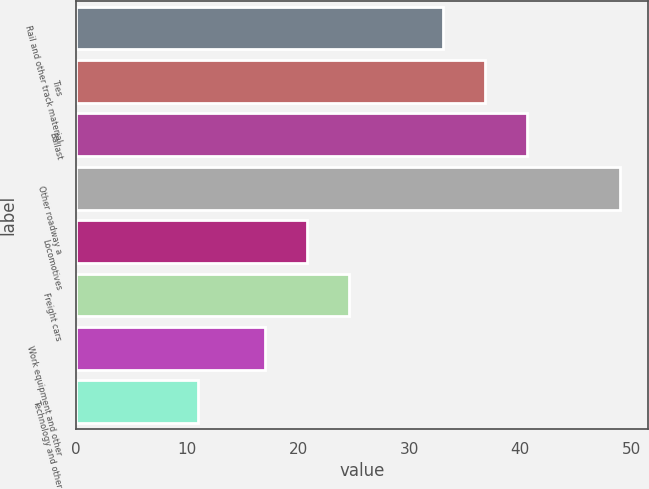Convert chart to OTSL. <chart><loc_0><loc_0><loc_500><loc_500><bar_chart><fcel>Rail and other track material<fcel>Ties<fcel>Ballast<fcel>Other roadway a<fcel>Locomotives<fcel>Freight cars<fcel>Work equipment and other<fcel>Technology and other<nl><fcel>33<fcel>36.8<fcel>40.6<fcel>49<fcel>20.8<fcel>24.6<fcel>17<fcel>11<nl></chart> 